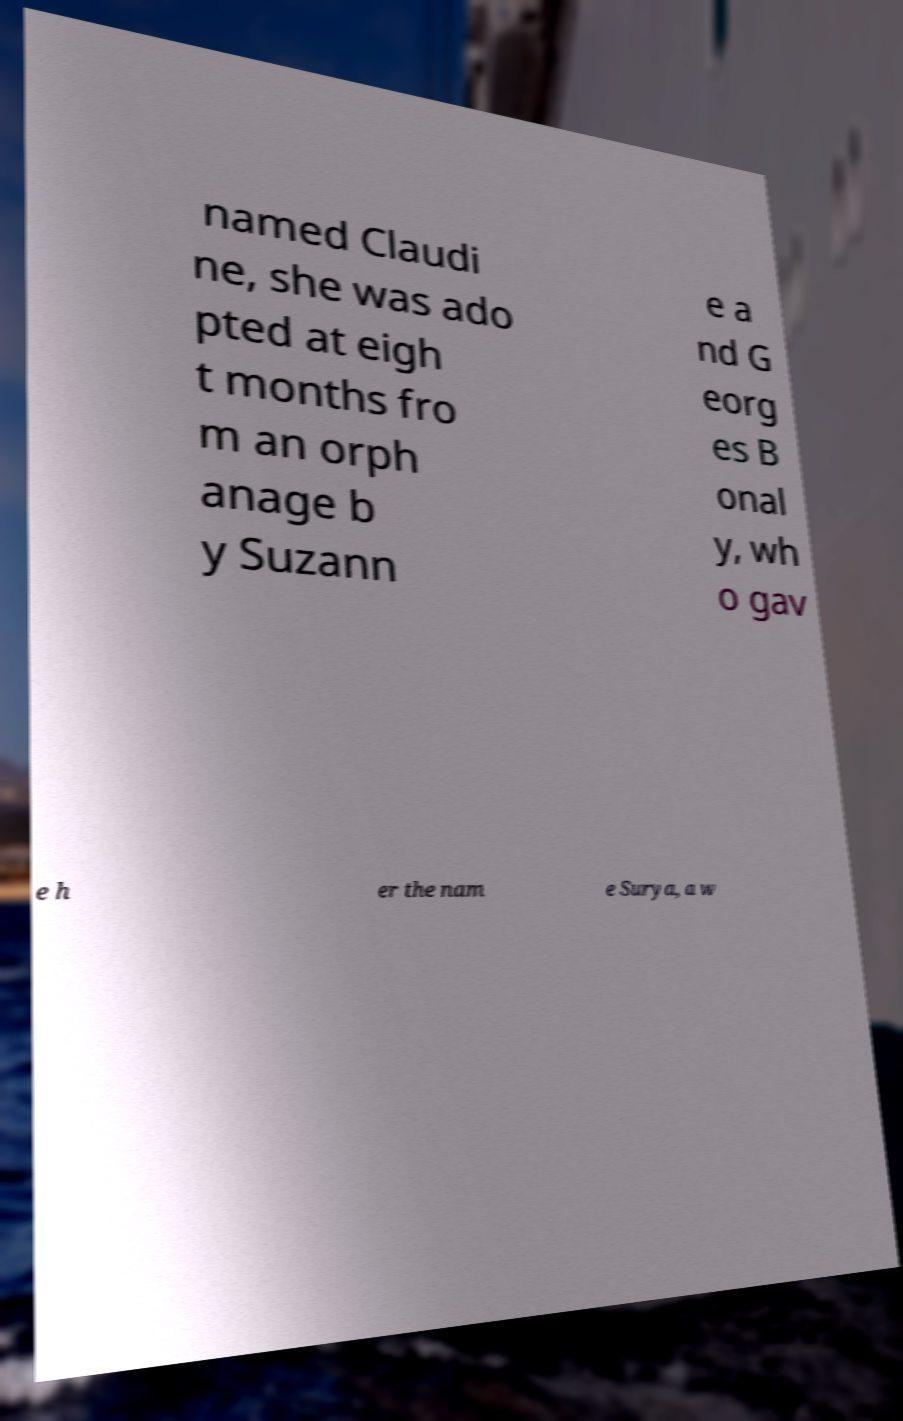Could you extract and type out the text from this image? named Claudi ne, she was ado pted at eigh t months fro m an orph anage b y Suzann e a nd G eorg es B onal y, wh o gav e h er the nam e Surya, a w 